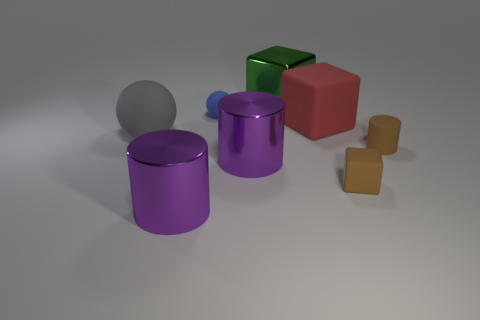Add 1 big purple objects. How many objects exist? 9 Subtract all balls. How many objects are left? 6 Add 3 purple objects. How many purple objects are left? 5 Add 4 red shiny spheres. How many red shiny spheres exist? 4 Subtract 0 red spheres. How many objects are left? 8 Subtract all big brown metallic spheres. Subtract all small things. How many objects are left? 5 